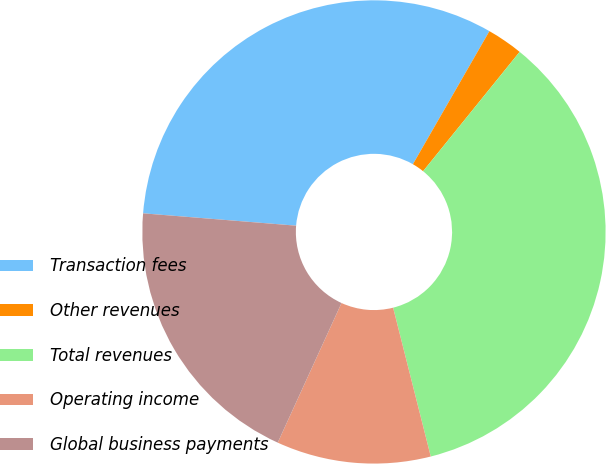Convert chart to OTSL. <chart><loc_0><loc_0><loc_500><loc_500><pie_chart><fcel>Transaction fees<fcel>Other revenues<fcel>Total revenues<fcel>Operating income<fcel>Global business payments<nl><fcel>32.02%<fcel>2.52%<fcel>35.23%<fcel>10.76%<fcel>19.46%<nl></chart> 